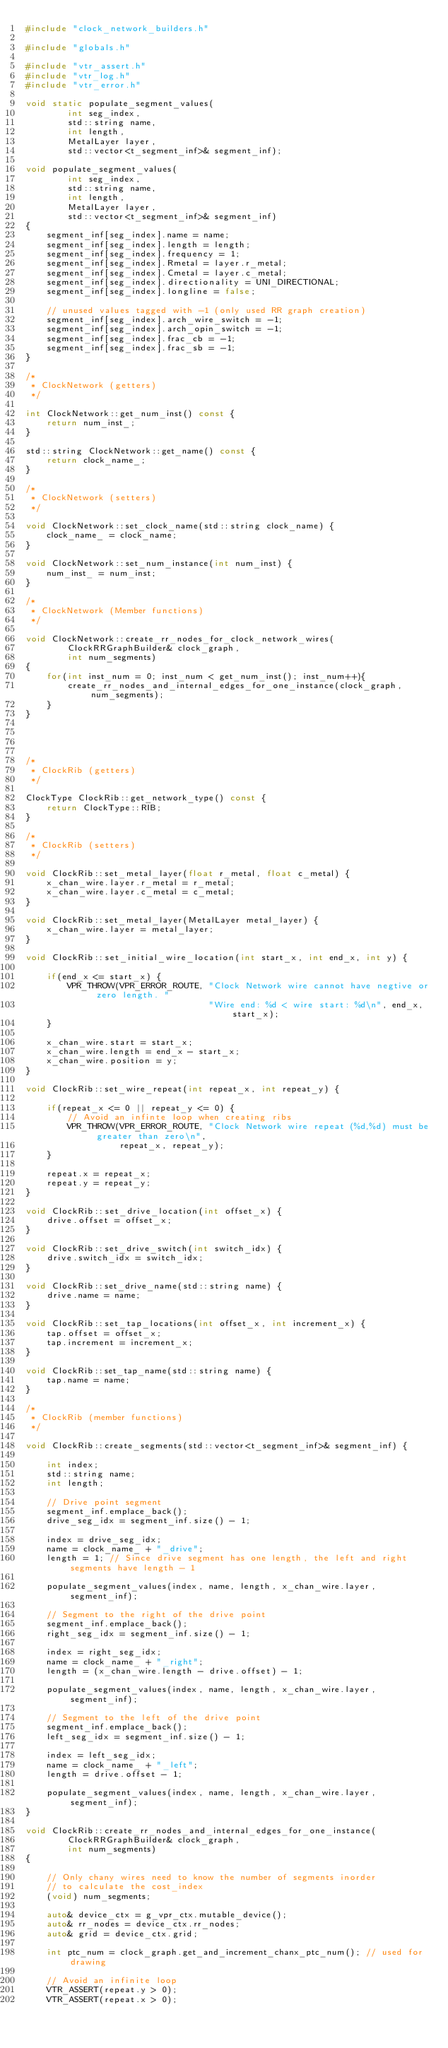<code> <loc_0><loc_0><loc_500><loc_500><_C++_>#include "clock_network_builders.h"

#include "globals.h"

#include "vtr_assert.h"
#include "vtr_log.h"
#include "vtr_error.h"

void static populate_segment_values(
        int seg_index,
        std::string name,
        int length,
        MetalLayer layer,
        std::vector<t_segment_inf>& segment_inf);

void populate_segment_values(
        int seg_index,
        std::string name,
        int length,
        MetalLayer layer,
        std::vector<t_segment_inf>& segment_inf)
{
    segment_inf[seg_index].name = name;
    segment_inf[seg_index].length = length;
    segment_inf[seg_index].frequency = 1;
    segment_inf[seg_index].Rmetal = layer.r_metal;
    segment_inf[seg_index].Cmetal = layer.c_metal;
    segment_inf[seg_index].directionality = UNI_DIRECTIONAL;
    segment_inf[seg_index].longline = false;

    // unused values tagged with -1 (only used RR graph creation)
    segment_inf[seg_index].arch_wire_switch = -1;
    segment_inf[seg_index].arch_opin_switch = -1;
    segment_inf[seg_index].frac_cb = -1;
    segment_inf[seg_index].frac_sb = -1;
}

/*
 * ClockNetwork (getters)
 */

int ClockNetwork::get_num_inst() const {
    return num_inst_;
}

std::string ClockNetwork::get_name() const {
    return clock_name_;
}

/*
 * ClockNetwork (setters)
 */

void ClockNetwork::set_clock_name(std::string clock_name) {
    clock_name_ = clock_name;
}

void ClockNetwork::set_num_instance(int num_inst) {
    num_inst_ = num_inst;
}

/*
 * ClockNetwork (Member functions)
 */

void ClockNetwork::create_rr_nodes_for_clock_network_wires(
        ClockRRGraphBuilder& clock_graph,
        int num_segments)
{
    for(int inst_num = 0; inst_num < get_num_inst(); inst_num++){
        create_rr_nodes_and_internal_edges_for_one_instance(clock_graph, num_segments);
    }
}




/*
 * ClockRib (getters)
 */

ClockType ClockRib::get_network_type() const {
    return ClockType::RIB;
}

/*
 * ClockRib (setters)
 */

void ClockRib::set_metal_layer(float r_metal, float c_metal) {
    x_chan_wire.layer.r_metal = r_metal;
    x_chan_wire.layer.c_metal = c_metal;
}

void ClockRib::set_metal_layer(MetalLayer metal_layer) {
    x_chan_wire.layer = metal_layer;
}

void ClockRib::set_initial_wire_location(int start_x, int end_x, int y) {

    if(end_x <= start_x) {
        VPR_THROW(VPR_ERROR_ROUTE, "Clock Network wire cannot have negtive or zero length. "
                                   "Wire end: %d < wire start: %d\n", end_x, start_x);
    }

    x_chan_wire.start = start_x;
    x_chan_wire.length = end_x - start_x;
    x_chan_wire.position = y;
}

void ClockRib::set_wire_repeat(int repeat_x, int repeat_y) {

    if(repeat_x <= 0 || repeat_y <= 0) {
        // Avoid an infinte loop when creating ribs
        VPR_THROW(VPR_ERROR_ROUTE, "Clock Network wire repeat (%d,%d) must be greater than zero\n",
                  repeat_x, repeat_y);
    }

    repeat.x = repeat_x;
    repeat.y = repeat_y;
}

void ClockRib::set_drive_location(int offset_x) {
    drive.offset = offset_x;
}

void ClockRib::set_drive_switch(int switch_idx) {
    drive.switch_idx = switch_idx;
}

void ClockRib::set_drive_name(std::string name) {
    drive.name = name;
}

void ClockRib::set_tap_locations(int offset_x, int increment_x) {
    tap.offset = offset_x;
    tap.increment = increment_x;
}

void ClockRib::set_tap_name(std::string name) {
    tap.name = name;
}

/*
 * ClockRib (member functions)
 */

void ClockRib::create_segments(std::vector<t_segment_inf>& segment_inf) {

    int index;
    std::string name;
    int length;

    // Drive point segment
    segment_inf.emplace_back();
    drive_seg_idx = segment_inf.size() - 1;

    index = drive_seg_idx;
    name = clock_name_ + "_drive";
    length = 1; // Since drive segment has one length, the left and right segments have length - 1

    populate_segment_values(index, name, length, x_chan_wire.layer, segment_inf);

    // Segment to the right of the drive point
    segment_inf.emplace_back();
    right_seg_idx = segment_inf.size() - 1;

    index = right_seg_idx;
    name = clock_name_ + "_right";
    length = (x_chan_wire.length - drive.offset) - 1;

    populate_segment_values(index, name, length, x_chan_wire.layer, segment_inf);

    // Segment to the left of the drive point
    segment_inf.emplace_back();
    left_seg_idx = segment_inf.size() - 1;

    index = left_seg_idx;
    name = clock_name_ + "_left";
    length = drive.offset - 1;

    populate_segment_values(index, name, length, x_chan_wire.layer, segment_inf);
}

void ClockRib::create_rr_nodes_and_internal_edges_for_one_instance(
        ClockRRGraphBuilder& clock_graph,
        int num_segments)
{

    // Only chany wires need to know the number of segments inorder
    // to calculate the cost_index
    (void) num_segments;

    auto& device_ctx = g_vpr_ctx.mutable_device();
    auto& rr_nodes = device_ctx.rr_nodes;
    auto& grid = device_ctx.grid;

    int ptc_num = clock_graph.get_and_increment_chanx_ptc_num(); // used for drawing

    // Avoid an infinite loop
    VTR_ASSERT(repeat.y > 0);
    VTR_ASSERT(repeat.x > 0);
</code> 